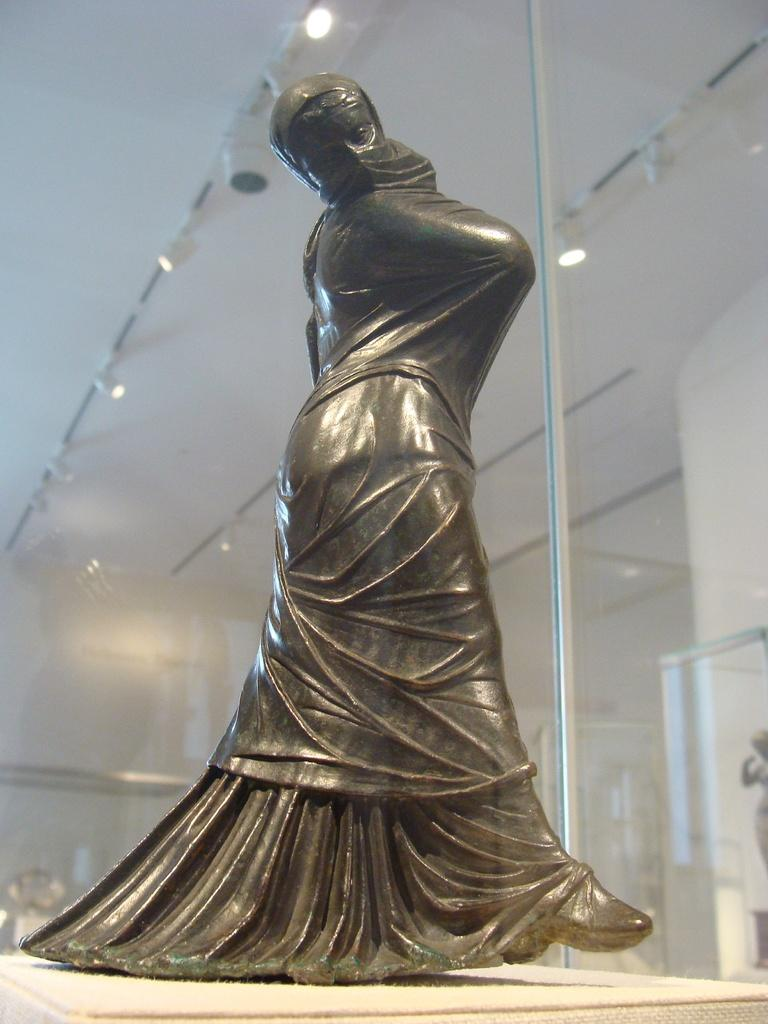What is the main subject in the image? There is a statue in the image. What can be seen behind the statue? There is a glass wall in the image. What type of tax is being discussed in the image? There is no discussion of tax in the image; it features a statue and a glass wall. Can you see any flies in the image? There are no flies present in the image. 